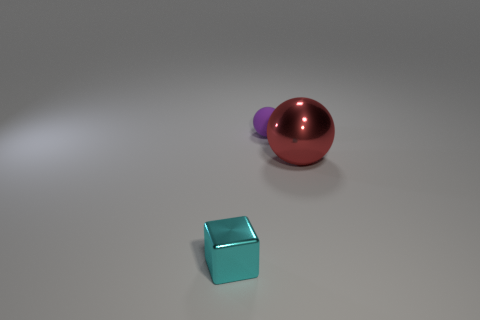There is a thing that is both to the left of the shiny sphere and in front of the tiny sphere; what is its material?
Your answer should be compact. Metal. There is a cyan cube that is made of the same material as the large red object; what size is it?
Keep it short and to the point. Small. There is a cyan shiny cube that is on the left side of the small purple object; how big is it?
Provide a succinct answer. Small. How many other blocks have the same size as the cyan cube?
Ensure brevity in your answer.  0. The metallic object that is the same size as the rubber sphere is what color?
Offer a terse response. Cyan. What is the color of the big sphere?
Ensure brevity in your answer.  Red. What is the material of the sphere that is in front of the purple thing?
Provide a short and direct response. Metal. What is the size of the other object that is the same shape as the purple thing?
Provide a short and direct response. Large. Are there fewer tiny things behind the tiny block than cyan shiny objects?
Give a very brief answer. No. Are there any shiny objects?
Provide a short and direct response. Yes. 